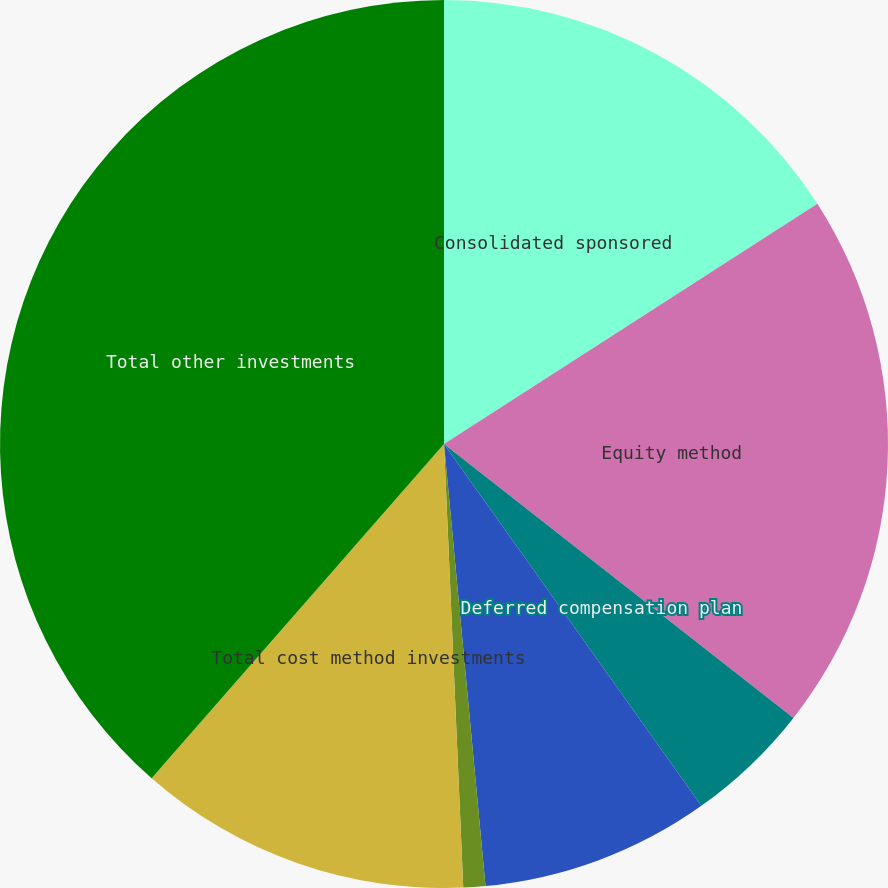Convert chart. <chart><loc_0><loc_0><loc_500><loc_500><pie_chart><fcel>Consolidated sponsored<fcel>Equity method<fcel>Deferred compensation plan<fcel>Federal Reserve Bank stock<fcel>Other<fcel>Total cost method investments<fcel>Total other investments<nl><fcel>15.9%<fcel>19.68%<fcel>4.58%<fcel>8.35%<fcel>0.8%<fcel>12.13%<fcel>38.56%<nl></chart> 